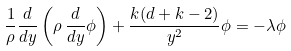Convert formula to latex. <formula><loc_0><loc_0><loc_500><loc_500>\frac { 1 } { \rho } \frac { d } { d y } \left ( \rho \, \frac { d } { d y } \phi \right ) + \frac { k ( d + k - 2 ) } { y ^ { 2 } } \phi = - \lambda \phi</formula> 